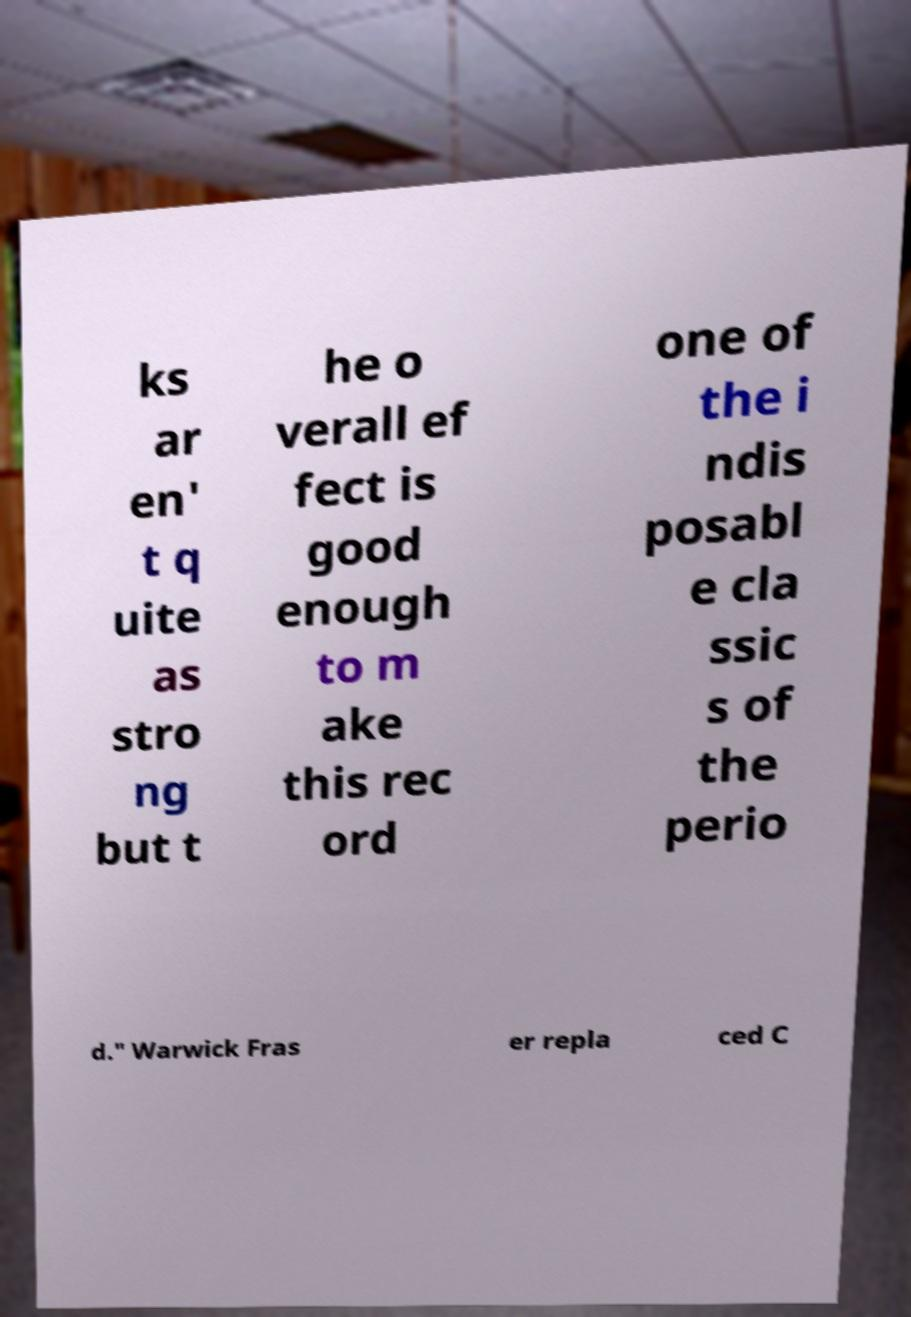Please read and relay the text visible in this image. What does it say? ks ar en' t q uite as stro ng but t he o verall ef fect is good enough to m ake this rec ord one of the i ndis posabl e cla ssic s of the perio d." Warwick Fras er repla ced C 